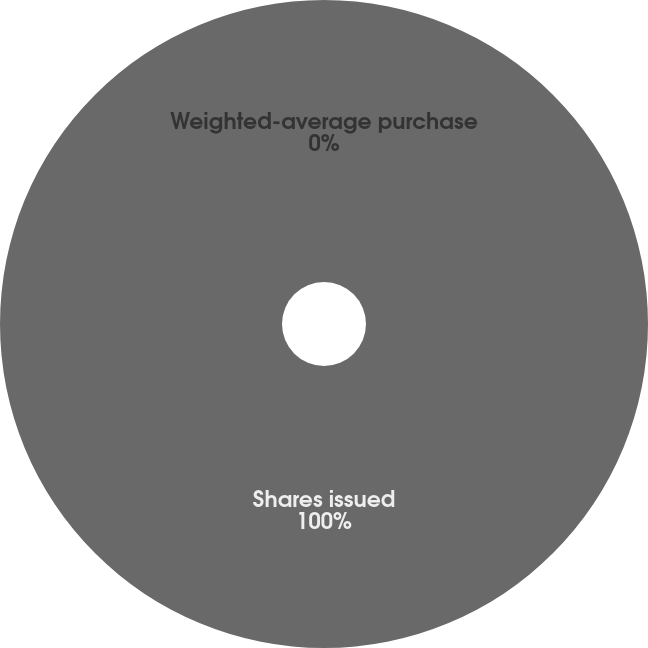<chart> <loc_0><loc_0><loc_500><loc_500><pie_chart><fcel>Shares issued<fcel>Weighted-average purchase<nl><fcel>100.0%<fcel>0.0%<nl></chart> 